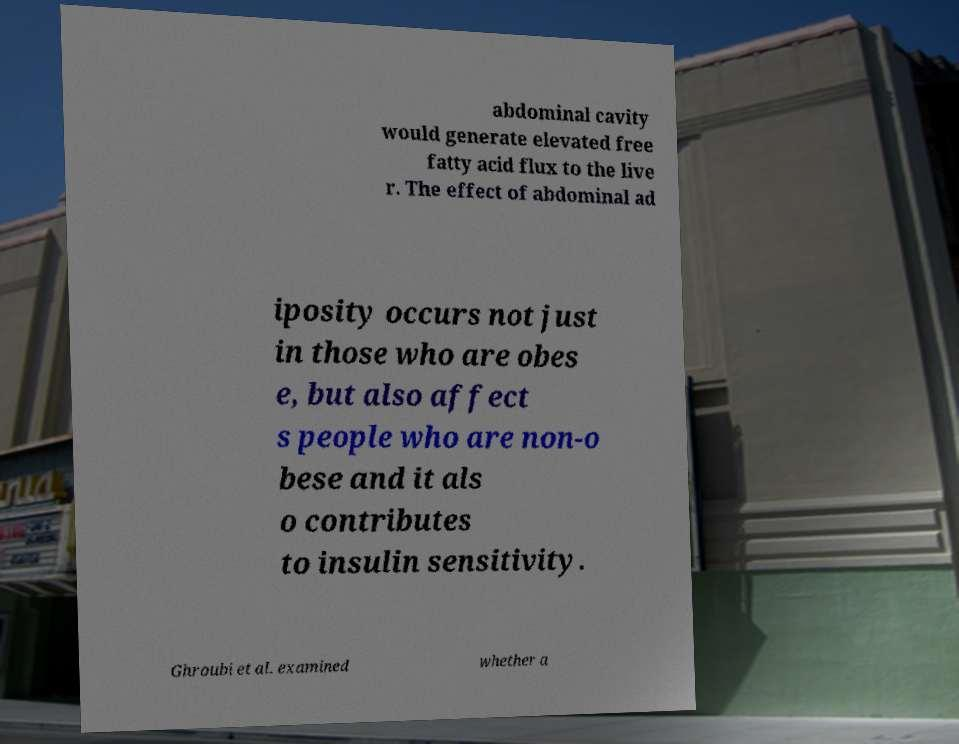I need the written content from this picture converted into text. Can you do that? abdominal cavity would generate elevated free fatty acid flux to the live r. The effect of abdominal ad iposity occurs not just in those who are obes e, but also affect s people who are non-o bese and it als o contributes to insulin sensitivity. Ghroubi et al. examined whether a 